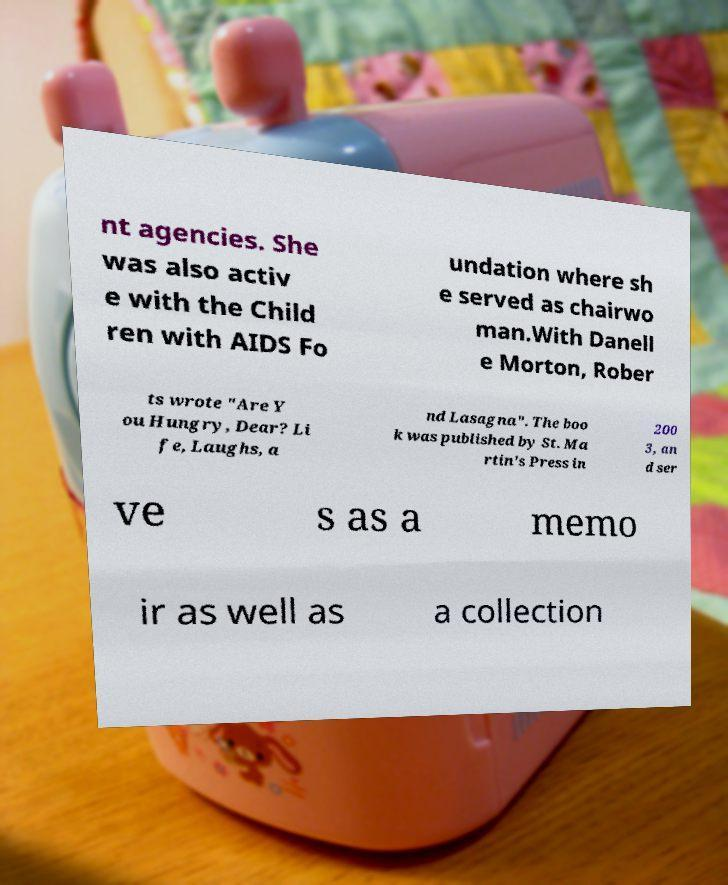Could you assist in decoding the text presented in this image and type it out clearly? nt agencies. She was also activ e with the Child ren with AIDS Fo undation where sh e served as chairwo man.With Danell e Morton, Rober ts wrote "Are Y ou Hungry, Dear? Li fe, Laughs, a nd Lasagna". The boo k was published by St. Ma rtin's Press in 200 3, an d ser ve s as a memo ir as well as a collection 